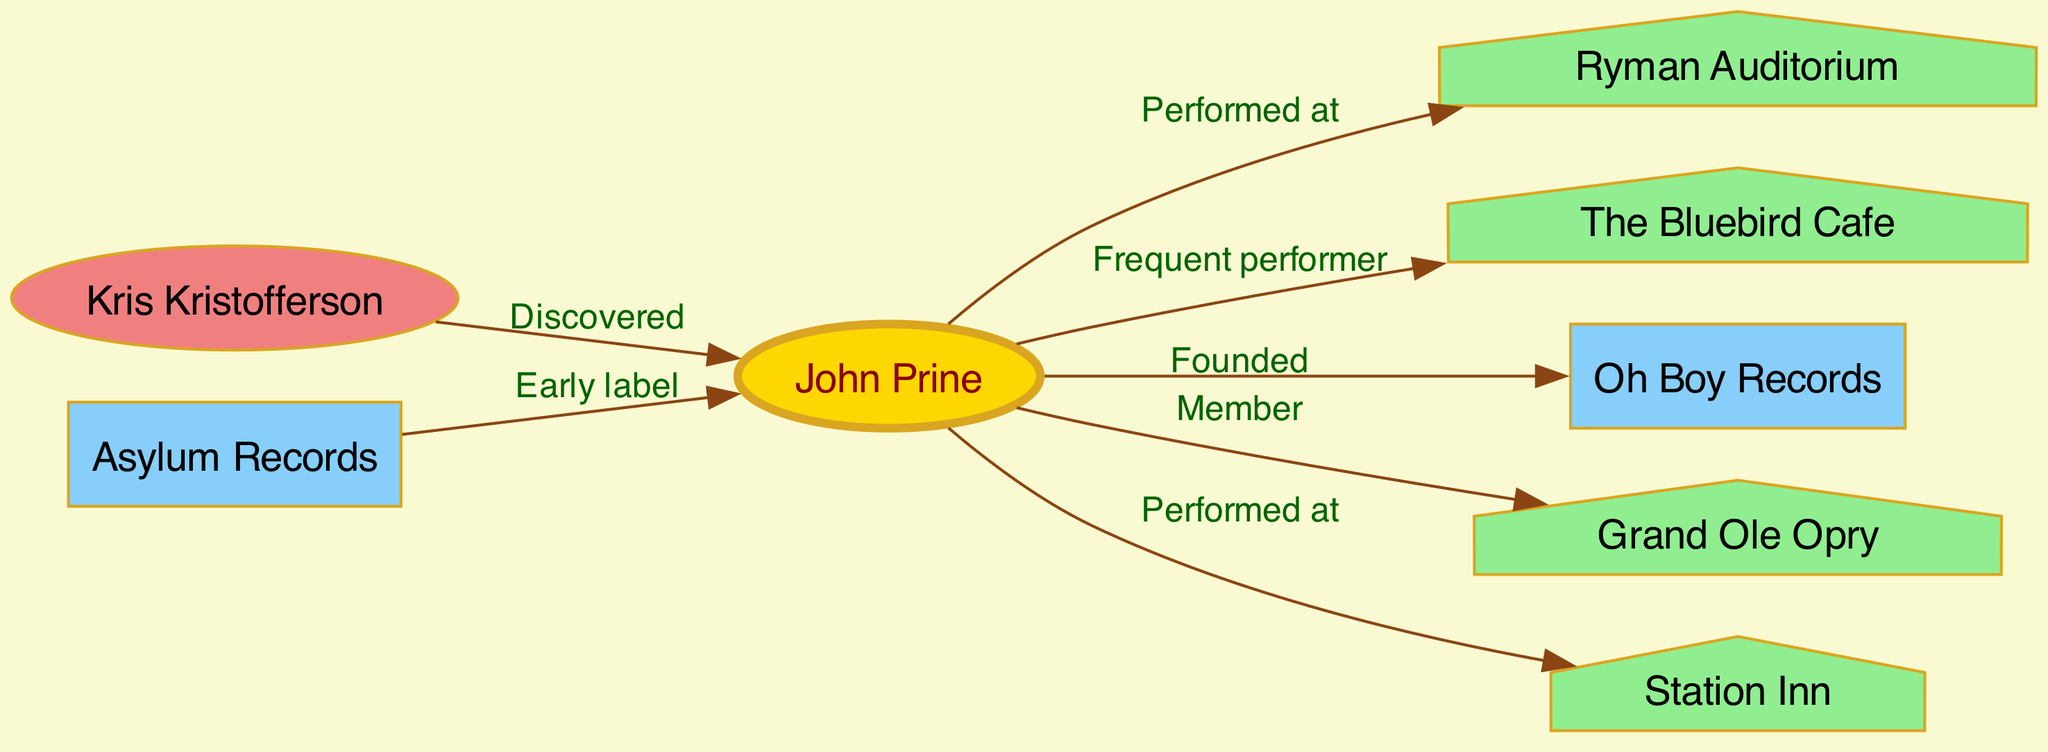What is the total number of nodes in the diagram? The diagram contains various entities such as artists, venues, and record labels. By counting each unique entry under 'nodes', we find a total of 8 nodes present in the diagram which includes John Prine, Ryman Auditorium, The Bluebird Cafe, Oh Boy Records, Grand Ole Opry, Kris Kristofferson, Station Inn, and Asylum Records.
Answer: 8 Which venue is connected to John Prine and labeled as a house? In the diagram, there are multiple venues associated with John Prine, but we need to identify the one that is specifically marked with a house shape—this is the Grand Ole Opry, which is noted for its significance in the country music scene.
Answer: Grand Ole Opry Who discovered John Prine? The connection in the diagram shows that Kris Kristofferson is linked to John Prine with the label "Discovered." This indicates that he played a role in bringing John Prine's talent to wider attention within the music community.
Answer: Kris Kristofferson How many edges are leading from John Prine to various nodes? The edges from John Prine connect him to several venues and records, which can be counted by examining all outgoing edges from the 'JohnPrine' node. There are 5 edges originating from him, which indicate numerous relationships he has within the Nashville music scene.
Answer: 5 Which label is associated with John Prine as an early record label? The diagram indicates that Asylum Records is connected to John Prine with the label "Early label," signifying it was one of the first labels he worked with when beginning his career.
Answer: Asylum Records What type of connection is noted between John Prine and the Bluebird Cafe? The relationship depicted in the diagram is labeled "Frequent performer," suggesting that John Prine regularly performed at the Bluebird Cafe. This reflects his prominent role in the venue's music community.
Answer: Frequent performer Which record label did John Prine found according to the diagram? According to the edges in the diagram, John Prine is connected to Oh Boy Records with the label "Founded," indicating that he was instrumental in establishing this record label.
Answer: Oh Boy Records How many venues has John Prine performed at according to the diagram? By examining all the outgoing edges from the 'JohnPrine' node to venues, it can be seen that he has performed at three distinct locations: Ryman Auditorium, The Bluebird Cafe, and Station Inn.
Answer: 3 What is the relationship between Asylum Records and John Prine? The edge connecting Asylum Records to John Prine is labeled "Early label," which shows that Asylum Records was one of the first labels associated with John Prine during his career in country music.
Answer: Early label 